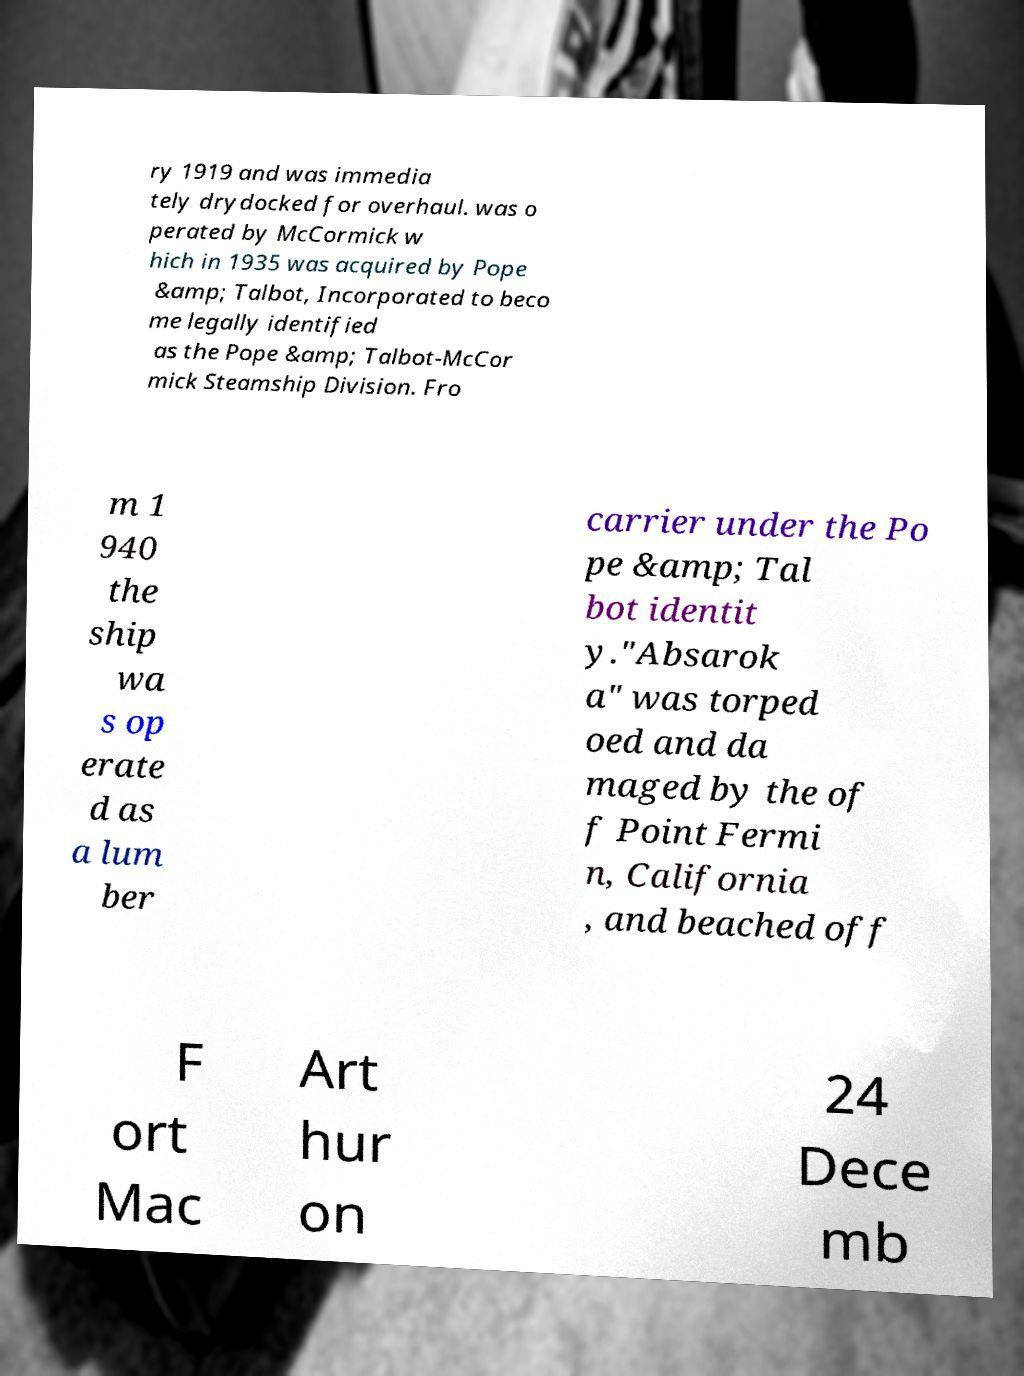Please read and relay the text visible in this image. What does it say? ry 1919 and was immedia tely drydocked for overhaul. was o perated by McCormick w hich in 1935 was acquired by Pope &amp; Talbot, Incorporated to beco me legally identified as the Pope &amp; Talbot-McCor mick Steamship Division. Fro m 1 940 the ship wa s op erate d as a lum ber carrier under the Po pe &amp; Tal bot identit y."Absarok a" was torped oed and da maged by the of f Point Fermi n, California , and beached off F ort Mac Art hur on 24 Dece mb 